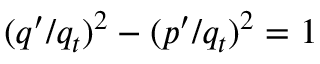<formula> <loc_0><loc_0><loc_500><loc_500>( q ^ { \prime } / q _ { t } ) ^ { 2 } - ( p ^ { \prime } / q _ { t } ) ^ { 2 } = 1</formula> 